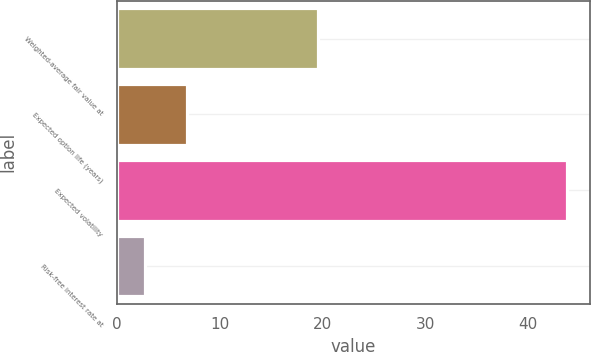Convert chart. <chart><loc_0><loc_0><loc_500><loc_500><bar_chart><fcel>Weighted-average fair value at<fcel>Expected option life (years)<fcel>Expected volatility<fcel>Risk-free interest rate at<nl><fcel>19.58<fcel>6.81<fcel>43.8<fcel>2.7<nl></chart> 